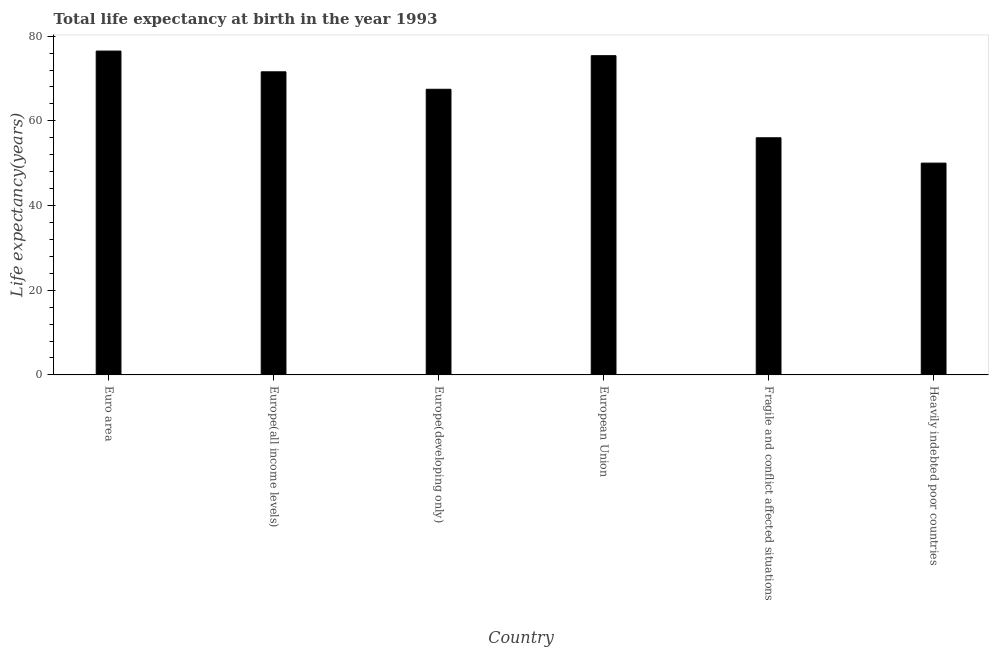What is the title of the graph?
Ensure brevity in your answer.  Total life expectancy at birth in the year 1993. What is the label or title of the Y-axis?
Your answer should be compact. Life expectancy(years). What is the life expectancy at birth in Euro area?
Your answer should be compact. 76.49. Across all countries, what is the maximum life expectancy at birth?
Provide a succinct answer. 76.49. Across all countries, what is the minimum life expectancy at birth?
Ensure brevity in your answer.  50.02. In which country was the life expectancy at birth maximum?
Keep it short and to the point. Euro area. In which country was the life expectancy at birth minimum?
Ensure brevity in your answer.  Heavily indebted poor countries. What is the sum of the life expectancy at birth?
Your answer should be compact. 396.96. What is the difference between the life expectancy at birth in Europe(developing only) and European Union?
Give a very brief answer. -7.93. What is the average life expectancy at birth per country?
Offer a very short reply. 66.16. What is the median life expectancy at birth?
Your response must be concise. 69.52. In how many countries, is the life expectancy at birth greater than 44 years?
Your answer should be compact. 6. What is the ratio of the life expectancy at birth in Euro area to that in Europe(all income levels)?
Offer a very short reply. 1.07. What is the difference between the highest and the second highest life expectancy at birth?
Give a very brief answer. 1.09. What is the difference between the highest and the lowest life expectancy at birth?
Your answer should be compact. 26.46. How many bars are there?
Your answer should be compact. 6. Are the values on the major ticks of Y-axis written in scientific E-notation?
Make the answer very short. No. What is the Life expectancy(years) of Euro area?
Offer a terse response. 76.49. What is the Life expectancy(years) in Europe(all income levels)?
Offer a terse response. 71.59. What is the Life expectancy(years) in Europe(developing only)?
Provide a short and direct response. 67.46. What is the Life expectancy(years) in European Union?
Give a very brief answer. 75.39. What is the Life expectancy(years) in Fragile and conflict affected situations?
Your answer should be very brief. 56.01. What is the Life expectancy(years) in Heavily indebted poor countries?
Your answer should be compact. 50.02. What is the difference between the Life expectancy(years) in Euro area and Europe(all income levels)?
Offer a very short reply. 4.9. What is the difference between the Life expectancy(years) in Euro area and Europe(developing only)?
Your response must be concise. 9.02. What is the difference between the Life expectancy(years) in Euro area and European Union?
Give a very brief answer. 1.09. What is the difference between the Life expectancy(years) in Euro area and Fragile and conflict affected situations?
Your answer should be very brief. 20.48. What is the difference between the Life expectancy(years) in Euro area and Heavily indebted poor countries?
Make the answer very short. 26.46. What is the difference between the Life expectancy(years) in Europe(all income levels) and Europe(developing only)?
Provide a succinct answer. 4.12. What is the difference between the Life expectancy(years) in Europe(all income levels) and European Union?
Ensure brevity in your answer.  -3.81. What is the difference between the Life expectancy(years) in Europe(all income levels) and Fragile and conflict affected situations?
Offer a terse response. 15.58. What is the difference between the Life expectancy(years) in Europe(all income levels) and Heavily indebted poor countries?
Your answer should be compact. 21.56. What is the difference between the Life expectancy(years) in Europe(developing only) and European Union?
Offer a terse response. -7.93. What is the difference between the Life expectancy(years) in Europe(developing only) and Fragile and conflict affected situations?
Your answer should be very brief. 11.45. What is the difference between the Life expectancy(years) in Europe(developing only) and Heavily indebted poor countries?
Provide a succinct answer. 17.44. What is the difference between the Life expectancy(years) in European Union and Fragile and conflict affected situations?
Your answer should be very brief. 19.38. What is the difference between the Life expectancy(years) in European Union and Heavily indebted poor countries?
Provide a succinct answer. 25.37. What is the difference between the Life expectancy(years) in Fragile and conflict affected situations and Heavily indebted poor countries?
Provide a short and direct response. 5.99. What is the ratio of the Life expectancy(years) in Euro area to that in Europe(all income levels)?
Your answer should be very brief. 1.07. What is the ratio of the Life expectancy(years) in Euro area to that in Europe(developing only)?
Keep it short and to the point. 1.13. What is the ratio of the Life expectancy(years) in Euro area to that in Fragile and conflict affected situations?
Offer a very short reply. 1.37. What is the ratio of the Life expectancy(years) in Euro area to that in Heavily indebted poor countries?
Provide a succinct answer. 1.53. What is the ratio of the Life expectancy(years) in Europe(all income levels) to that in Europe(developing only)?
Provide a succinct answer. 1.06. What is the ratio of the Life expectancy(years) in Europe(all income levels) to that in European Union?
Keep it short and to the point. 0.95. What is the ratio of the Life expectancy(years) in Europe(all income levels) to that in Fragile and conflict affected situations?
Provide a short and direct response. 1.28. What is the ratio of the Life expectancy(years) in Europe(all income levels) to that in Heavily indebted poor countries?
Your answer should be very brief. 1.43. What is the ratio of the Life expectancy(years) in Europe(developing only) to that in European Union?
Provide a short and direct response. 0.9. What is the ratio of the Life expectancy(years) in Europe(developing only) to that in Fragile and conflict affected situations?
Ensure brevity in your answer.  1.2. What is the ratio of the Life expectancy(years) in Europe(developing only) to that in Heavily indebted poor countries?
Give a very brief answer. 1.35. What is the ratio of the Life expectancy(years) in European Union to that in Fragile and conflict affected situations?
Provide a short and direct response. 1.35. What is the ratio of the Life expectancy(years) in European Union to that in Heavily indebted poor countries?
Offer a very short reply. 1.51. What is the ratio of the Life expectancy(years) in Fragile and conflict affected situations to that in Heavily indebted poor countries?
Offer a very short reply. 1.12. 